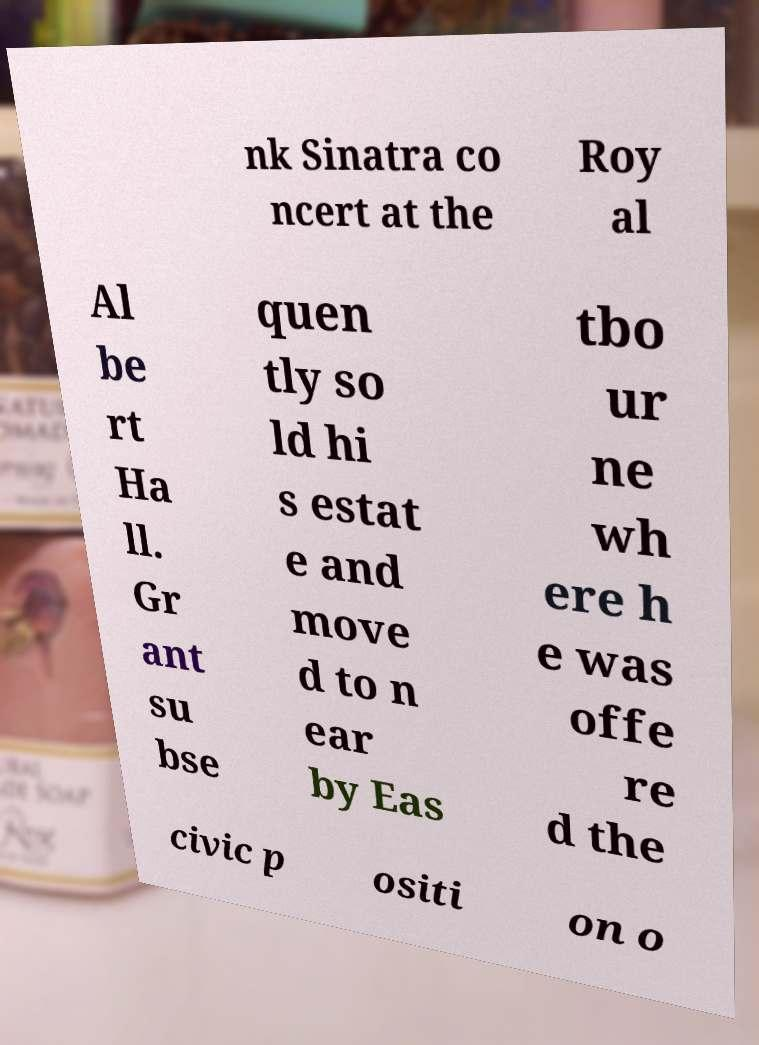There's text embedded in this image that I need extracted. Can you transcribe it verbatim? nk Sinatra co ncert at the Roy al Al be rt Ha ll. Gr ant su bse quen tly so ld hi s estat e and move d to n ear by Eas tbo ur ne wh ere h e was offe re d the civic p ositi on o 